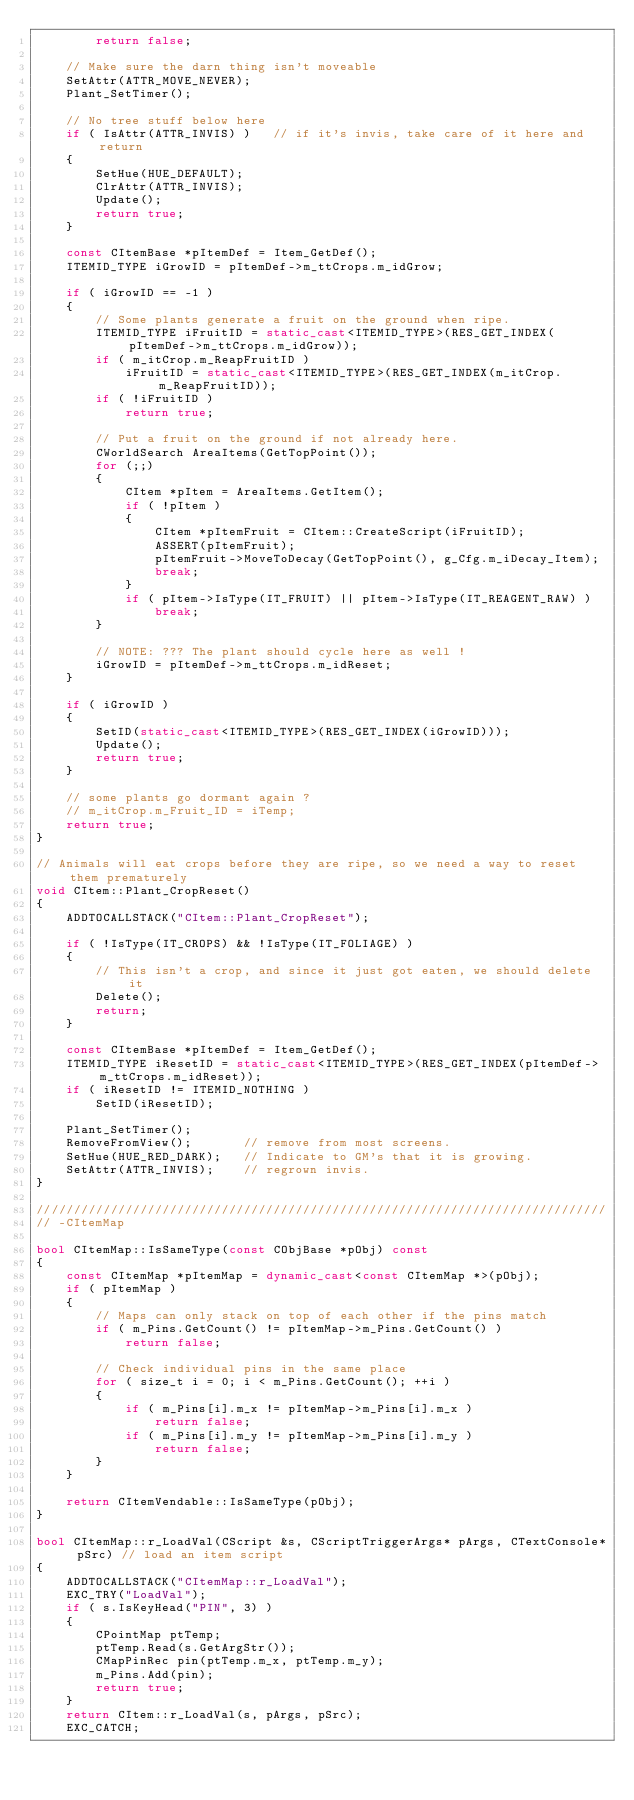<code> <loc_0><loc_0><loc_500><loc_500><_C++_>		return false;

	// Make sure the darn thing isn't moveable
	SetAttr(ATTR_MOVE_NEVER);
	Plant_SetTimer();

	// No tree stuff below here
	if ( IsAttr(ATTR_INVIS) )	// if it's invis, take care of it here and return
	{
		SetHue(HUE_DEFAULT);
		ClrAttr(ATTR_INVIS);
		Update();
		return true;
	}

	const CItemBase *pItemDef = Item_GetDef();
	ITEMID_TYPE iGrowID = pItemDef->m_ttCrops.m_idGrow;

	if ( iGrowID == -1 )
	{
		// Some plants generate a fruit on the ground when ripe.
		ITEMID_TYPE iFruitID = static_cast<ITEMID_TYPE>(RES_GET_INDEX(pItemDef->m_ttCrops.m_idGrow));
		if ( m_itCrop.m_ReapFruitID )
			iFruitID = static_cast<ITEMID_TYPE>(RES_GET_INDEX(m_itCrop.m_ReapFruitID));
		if ( !iFruitID )
			return true;

		// Put a fruit on the ground if not already here.
		CWorldSearch AreaItems(GetTopPoint());
		for (;;)
		{
			CItem *pItem = AreaItems.GetItem();
			if ( !pItem )
			{
				CItem *pItemFruit = CItem::CreateScript(iFruitID);
				ASSERT(pItemFruit);
				pItemFruit->MoveToDecay(GetTopPoint(), g_Cfg.m_iDecay_Item);
				break;
			}
			if ( pItem->IsType(IT_FRUIT) || pItem->IsType(IT_REAGENT_RAW) )
				break;
		}

		// NOTE: ??? The plant should cycle here as well !
		iGrowID = pItemDef->m_ttCrops.m_idReset;
	}

	if ( iGrowID )
	{
		SetID(static_cast<ITEMID_TYPE>(RES_GET_INDEX(iGrowID)));
		Update();
		return true;
	}

	// some plants go dormant again ?
	// m_itCrop.m_Fruit_ID = iTemp;
	return true;
}

// Animals will eat crops before they are ripe, so we need a way to reset them prematurely
void CItem::Plant_CropReset()
{
	ADDTOCALLSTACK("CItem::Plant_CropReset");

	if ( !IsType(IT_CROPS) && !IsType(IT_FOLIAGE) )
	{
		// This isn't a crop, and since it just got eaten, we should delete it
		Delete();
		return;
	}

	const CItemBase *pItemDef = Item_GetDef();
	ITEMID_TYPE iResetID = static_cast<ITEMID_TYPE>(RES_GET_INDEX(pItemDef->m_ttCrops.m_idReset));
	if ( iResetID != ITEMID_NOTHING )
		SetID(iResetID);

	Plant_SetTimer();
	RemoveFromView();		// remove from most screens.
	SetHue(HUE_RED_DARK);	// Indicate to GM's that it is growing.
	SetAttr(ATTR_INVIS);	// regrown invis.
}

/////////////////////////////////////////////////////////////////////////////
// -CItemMap

bool CItemMap::IsSameType(const CObjBase *pObj) const
{
	const CItemMap *pItemMap = dynamic_cast<const CItemMap *>(pObj);
	if ( pItemMap )
	{
		// Maps can only stack on top of each other if the pins match
		if ( m_Pins.GetCount() != pItemMap->m_Pins.GetCount() )
			return false;

		// Check individual pins in the same place
		for ( size_t i = 0; i < m_Pins.GetCount(); ++i )
		{
			if ( m_Pins[i].m_x != pItemMap->m_Pins[i].m_x )
				return false;
			if ( m_Pins[i].m_y != pItemMap->m_Pins[i].m_y )
				return false;
		}
	}

	return CItemVendable::IsSameType(pObj);
}

bool CItemMap::r_LoadVal(CScript &s, CScriptTriggerArgs* pArgs, CTextConsole* pSrc)	// load an item script
{
	ADDTOCALLSTACK("CItemMap::r_LoadVal");
	EXC_TRY("LoadVal");
	if ( s.IsKeyHead("PIN", 3) )
	{
		CPointMap ptTemp;
		ptTemp.Read(s.GetArgStr());
		CMapPinRec pin(ptTemp.m_x, ptTemp.m_y);
		m_Pins.Add(pin);
		return true;
	}
	return CItem::r_LoadVal(s, pArgs, pSrc);
	EXC_CATCH;
</code> 